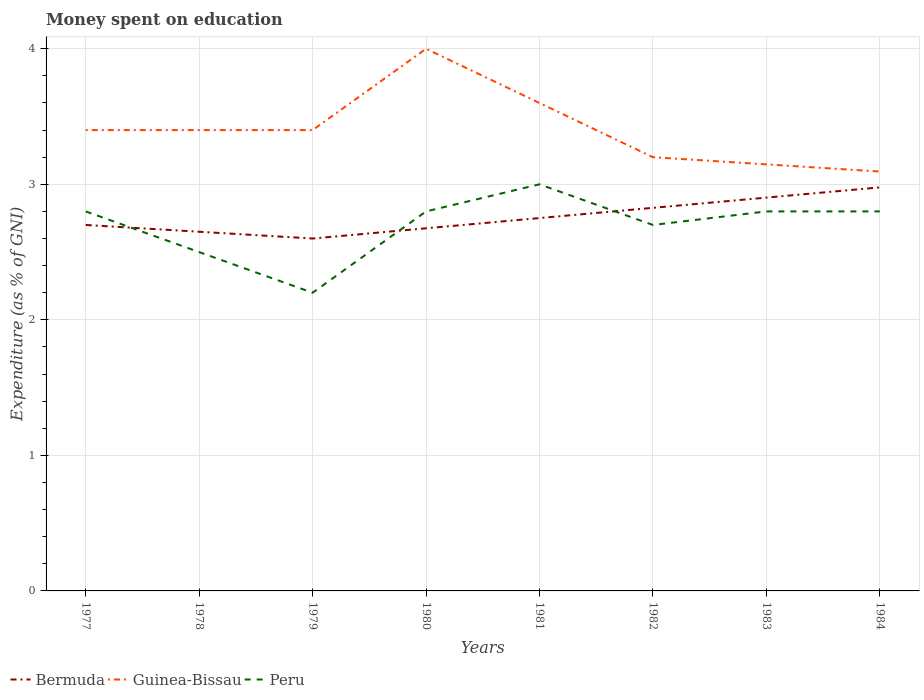How many different coloured lines are there?
Offer a very short reply. 3. Does the line corresponding to Peru intersect with the line corresponding to Bermuda?
Your answer should be very brief. Yes. Is the number of lines equal to the number of legend labels?
Make the answer very short. Yes. Across all years, what is the maximum amount of money spent on education in Guinea-Bissau?
Keep it short and to the point. 3.09. In which year was the amount of money spent on education in Peru maximum?
Ensure brevity in your answer.  1979. What is the total amount of money spent on education in Bermuda in the graph?
Offer a terse response. -0.3. What is the difference between the highest and the second highest amount of money spent on education in Guinea-Bissau?
Ensure brevity in your answer.  0.91. Is the amount of money spent on education in Peru strictly greater than the amount of money spent on education in Guinea-Bissau over the years?
Provide a succinct answer. Yes. How many lines are there?
Offer a very short reply. 3. How many years are there in the graph?
Offer a very short reply. 8. Does the graph contain any zero values?
Offer a very short reply. No. How many legend labels are there?
Offer a very short reply. 3. How are the legend labels stacked?
Your answer should be compact. Horizontal. What is the title of the graph?
Offer a terse response. Money spent on education. Does "Faeroe Islands" appear as one of the legend labels in the graph?
Offer a very short reply. No. What is the label or title of the Y-axis?
Provide a succinct answer. Expenditure (as % of GNI). What is the Expenditure (as % of GNI) in Bermuda in 1977?
Give a very brief answer. 2.7. What is the Expenditure (as % of GNI) in Guinea-Bissau in 1977?
Your answer should be compact. 3.4. What is the Expenditure (as % of GNI) in Peru in 1977?
Provide a short and direct response. 2.8. What is the Expenditure (as % of GNI) in Bermuda in 1978?
Your answer should be very brief. 2.65. What is the Expenditure (as % of GNI) of Guinea-Bissau in 1978?
Provide a succinct answer. 3.4. What is the Expenditure (as % of GNI) in Peru in 1978?
Your answer should be very brief. 2.5. What is the Expenditure (as % of GNI) in Bermuda in 1979?
Provide a succinct answer. 2.6. What is the Expenditure (as % of GNI) of Peru in 1979?
Make the answer very short. 2.2. What is the Expenditure (as % of GNI) of Bermuda in 1980?
Your answer should be compact. 2.68. What is the Expenditure (as % of GNI) of Guinea-Bissau in 1980?
Give a very brief answer. 4. What is the Expenditure (as % of GNI) of Bermuda in 1981?
Your answer should be very brief. 2.75. What is the Expenditure (as % of GNI) of Bermuda in 1982?
Give a very brief answer. 2.83. What is the Expenditure (as % of GNI) in Bermuda in 1983?
Offer a very short reply. 2.9. What is the Expenditure (as % of GNI) of Guinea-Bissau in 1983?
Provide a short and direct response. 3.15. What is the Expenditure (as % of GNI) in Bermuda in 1984?
Offer a terse response. 2.98. What is the Expenditure (as % of GNI) in Guinea-Bissau in 1984?
Give a very brief answer. 3.09. Across all years, what is the maximum Expenditure (as % of GNI) of Bermuda?
Your answer should be compact. 2.98. Across all years, what is the maximum Expenditure (as % of GNI) of Guinea-Bissau?
Offer a very short reply. 4. Across all years, what is the minimum Expenditure (as % of GNI) in Bermuda?
Ensure brevity in your answer.  2.6. Across all years, what is the minimum Expenditure (as % of GNI) of Guinea-Bissau?
Keep it short and to the point. 3.09. Across all years, what is the minimum Expenditure (as % of GNI) in Peru?
Make the answer very short. 2.2. What is the total Expenditure (as % of GNI) of Bermuda in the graph?
Offer a terse response. 22.08. What is the total Expenditure (as % of GNI) of Guinea-Bissau in the graph?
Offer a terse response. 27.24. What is the total Expenditure (as % of GNI) of Peru in the graph?
Your answer should be compact. 21.6. What is the difference between the Expenditure (as % of GNI) in Bermuda in 1977 and that in 1979?
Ensure brevity in your answer.  0.1. What is the difference between the Expenditure (as % of GNI) of Guinea-Bissau in 1977 and that in 1979?
Your response must be concise. 0. What is the difference between the Expenditure (as % of GNI) in Peru in 1977 and that in 1979?
Make the answer very short. 0.6. What is the difference between the Expenditure (as % of GNI) in Bermuda in 1977 and that in 1980?
Give a very brief answer. 0.02. What is the difference between the Expenditure (as % of GNI) in Bermuda in 1977 and that in 1981?
Provide a short and direct response. -0.05. What is the difference between the Expenditure (as % of GNI) of Guinea-Bissau in 1977 and that in 1981?
Your answer should be very brief. -0.2. What is the difference between the Expenditure (as % of GNI) in Bermuda in 1977 and that in 1982?
Your answer should be compact. -0.13. What is the difference between the Expenditure (as % of GNI) in Guinea-Bissau in 1977 and that in 1982?
Offer a very short reply. 0.2. What is the difference between the Expenditure (as % of GNI) of Peru in 1977 and that in 1982?
Make the answer very short. 0.1. What is the difference between the Expenditure (as % of GNI) in Bermuda in 1977 and that in 1983?
Offer a terse response. -0.2. What is the difference between the Expenditure (as % of GNI) in Guinea-Bissau in 1977 and that in 1983?
Provide a short and direct response. 0.25. What is the difference between the Expenditure (as % of GNI) in Peru in 1977 and that in 1983?
Give a very brief answer. 0. What is the difference between the Expenditure (as % of GNI) in Bermuda in 1977 and that in 1984?
Give a very brief answer. -0.28. What is the difference between the Expenditure (as % of GNI) in Guinea-Bissau in 1977 and that in 1984?
Provide a succinct answer. 0.31. What is the difference between the Expenditure (as % of GNI) in Peru in 1977 and that in 1984?
Your answer should be very brief. 0. What is the difference between the Expenditure (as % of GNI) in Peru in 1978 and that in 1979?
Provide a succinct answer. 0.3. What is the difference between the Expenditure (as % of GNI) in Bermuda in 1978 and that in 1980?
Make the answer very short. -0.03. What is the difference between the Expenditure (as % of GNI) of Guinea-Bissau in 1978 and that in 1980?
Your answer should be very brief. -0.6. What is the difference between the Expenditure (as % of GNI) of Peru in 1978 and that in 1980?
Provide a short and direct response. -0.3. What is the difference between the Expenditure (as % of GNI) of Bermuda in 1978 and that in 1981?
Offer a terse response. -0.1. What is the difference between the Expenditure (as % of GNI) of Guinea-Bissau in 1978 and that in 1981?
Your answer should be very brief. -0.2. What is the difference between the Expenditure (as % of GNI) in Bermuda in 1978 and that in 1982?
Provide a short and direct response. -0.18. What is the difference between the Expenditure (as % of GNI) in Bermuda in 1978 and that in 1983?
Your answer should be very brief. -0.25. What is the difference between the Expenditure (as % of GNI) of Guinea-Bissau in 1978 and that in 1983?
Your answer should be very brief. 0.25. What is the difference between the Expenditure (as % of GNI) of Peru in 1978 and that in 1983?
Provide a short and direct response. -0.3. What is the difference between the Expenditure (as % of GNI) of Bermuda in 1978 and that in 1984?
Provide a succinct answer. -0.33. What is the difference between the Expenditure (as % of GNI) of Guinea-Bissau in 1978 and that in 1984?
Your answer should be compact. 0.31. What is the difference between the Expenditure (as % of GNI) of Peru in 1978 and that in 1984?
Keep it short and to the point. -0.3. What is the difference between the Expenditure (as % of GNI) of Bermuda in 1979 and that in 1980?
Offer a very short reply. -0.08. What is the difference between the Expenditure (as % of GNI) of Bermuda in 1979 and that in 1981?
Your response must be concise. -0.15. What is the difference between the Expenditure (as % of GNI) of Guinea-Bissau in 1979 and that in 1981?
Your answer should be compact. -0.2. What is the difference between the Expenditure (as % of GNI) of Bermuda in 1979 and that in 1982?
Offer a very short reply. -0.23. What is the difference between the Expenditure (as % of GNI) in Bermuda in 1979 and that in 1983?
Offer a terse response. -0.3. What is the difference between the Expenditure (as % of GNI) in Guinea-Bissau in 1979 and that in 1983?
Provide a succinct answer. 0.25. What is the difference between the Expenditure (as % of GNI) of Bermuda in 1979 and that in 1984?
Provide a short and direct response. -0.38. What is the difference between the Expenditure (as % of GNI) in Guinea-Bissau in 1979 and that in 1984?
Keep it short and to the point. 0.31. What is the difference between the Expenditure (as % of GNI) of Bermuda in 1980 and that in 1981?
Your answer should be compact. -0.08. What is the difference between the Expenditure (as % of GNI) of Guinea-Bissau in 1980 and that in 1981?
Provide a short and direct response. 0.4. What is the difference between the Expenditure (as % of GNI) of Peru in 1980 and that in 1981?
Offer a terse response. -0.2. What is the difference between the Expenditure (as % of GNI) in Bermuda in 1980 and that in 1982?
Offer a very short reply. -0.15. What is the difference between the Expenditure (as % of GNI) in Guinea-Bissau in 1980 and that in 1982?
Keep it short and to the point. 0.8. What is the difference between the Expenditure (as % of GNI) of Peru in 1980 and that in 1982?
Offer a very short reply. 0.1. What is the difference between the Expenditure (as % of GNI) in Bermuda in 1980 and that in 1983?
Offer a terse response. -0.23. What is the difference between the Expenditure (as % of GNI) in Guinea-Bissau in 1980 and that in 1983?
Keep it short and to the point. 0.85. What is the difference between the Expenditure (as % of GNI) of Bermuda in 1980 and that in 1984?
Provide a succinct answer. -0.3. What is the difference between the Expenditure (as % of GNI) of Guinea-Bissau in 1980 and that in 1984?
Your answer should be very brief. 0.91. What is the difference between the Expenditure (as % of GNI) in Bermuda in 1981 and that in 1982?
Provide a short and direct response. -0.08. What is the difference between the Expenditure (as % of GNI) in Guinea-Bissau in 1981 and that in 1982?
Your answer should be very brief. 0.4. What is the difference between the Expenditure (as % of GNI) of Bermuda in 1981 and that in 1983?
Provide a succinct answer. -0.15. What is the difference between the Expenditure (as % of GNI) in Guinea-Bissau in 1981 and that in 1983?
Ensure brevity in your answer.  0.45. What is the difference between the Expenditure (as % of GNI) in Peru in 1981 and that in 1983?
Keep it short and to the point. 0.2. What is the difference between the Expenditure (as % of GNI) of Bermuda in 1981 and that in 1984?
Make the answer very short. -0.23. What is the difference between the Expenditure (as % of GNI) in Guinea-Bissau in 1981 and that in 1984?
Your answer should be compact. 0.51. What is the difference between the Expenditure (as % of GNI) of Bermuda in 1982 and that in 1983?
Ensure brevity in your answer.  -0.08. What is the difference between the Expenditure (as % of GNI) of Guinea-Bissau in 1982 and that in 1983?
Your response must be concise. 0.05. What is the difference between the Expenditure (as % of GNI) in Bermuda in 1982 and that in 1984?
Your response must be concise. -0.15. What is the difference between the Expenditure (as % of GNI) of Guinea-Bissau in 1982 and that in 1984?
Ensure brevity in your answer.  0.11. What is the difference between the Expenditure (as % of GNI) of Peru in 1982 and that in 1984?
Your response must be concise. -0.1. What is the difference between the Expenditure (as % of GNI) of Bermuda in 1983 and that in 1984?
Offer a terse response. -0.08. What is the difference between the Expenditure (as % of GNI) in Guinea-Bissau in 1983 and that in 1984?
Your answer should be very brief. 0.05. What is the difference between the Expenditure (as % of GNI) of Bermuda in 1977 and the Expenditure (as % of GNI) of Guinea-Bissau in 1978?
Offer a terse response. -0.7. What is the difference between the Expenditure (as % of GNI) of Guinea-Bissau in 1977 and the Expenditure (as % of GNI) of Peru in 1978?
Your response must be concise. 0.9. What is the difference between the Expenditure (as % of GNI) of Bermuda in 1977 and the Expenditure (as % of GNI) of Guinea-Bissau in 1979?
Offer a very short reply. -0.7. What is the difference between the Expenditure (as % of GNI) in Bermuda in 1977 and the Expenditure (as % of GNI) in Peru in 1980?
Provide a short and direct response. -0.1. What is the difference between the Expenditure (as % of GNI) in Bermuda in 1977 and the Expenditure (as % of GNI) in Guinea-Bissau in 1982?
Offer a terse response. -0.5. What is the difference between the Expenditure (as % of GNI) in Guinea-Bissau in 1977 and the Expenditure (as % of GNI) in Peru in 1982?
Your response must be concise. 0.7. What is the difference between the Expenditure (as % of GNI) in Bermuda in 1977 and the Expenditure (as % of GNI) in Guinea-Bissau in 1983?
Make the answer very short. -0.45. What is the difference between the Expenditure (as % of GNI) in Bermuda in 1977 and the Expenditure (as % of GNI) in Peru in 1983?
Keep it short and to the point. -0.1. What is the difference between the Expenditure (as % of GNI) in Bermuda in 1977 and the Expenditure (as % of GNI) in Guinea-Bissau in 1984?
Your response must be concise. -0.39. What is the difference between the Expenditure (as % of GNI) in Guinea-Bissau in 1977 and the Expenditure (as % of GNI) in Peru in 1984?
Your answer should be very brief. 0.6. What is the difference between the Expenditure (as % of GNI) of Bermuda in 1978 and the Expenditure (as % of GNI) of Guinea-Bissau in 1979?
Offer a terse response. -0.75. What is the difference between the Expenditure (as % of GNI) of Bermuda in 1978 and the Expenditure (as % of GNI) of Peru in 1979?
Provide a succinct answer. 0.45. What is the difference between the Expenditure (as % of GNI) in Bermuda in 1978 and the Expenditure (as % of GNI) in Guinea-Bissau in 1980?
Your answer should be very brief. -1.35. What is the difference between the Expenditure (as % of GNI) in Guinea-Bissau in 1978 and the Expenditure (as % of GNI) in Peru in 1980?
Your answer should be very brief. 0.6. What is the difference between the Expenditure (as % of GNI) of Bermuda in 1978 and the Expenditure (as % of GNI) of Guinea-Bissau in 1981?
Make the answer very short. -0.95. What is the difference between the Expenditure (as % of GNI) in Bermuda in 1978 and the Expenditure (as % of GNI) in Peru in 1981?
Your answer should be compact. -0.35. What is the difference between the Expenditure (as % of GNI) in Guinea-Bissau in 1978 and the Expenditure (as % of GNI) in Peru in 1981?
Keep it short and to the point. 0.4. What is the difference between the Expenditure (as % of GNI) of Bermuda in 1978 and the Expenditure (as % of GNI) of Guinea-Bissau in 1982?
Provide a short and direct response. -0.55. What is the difference between the Expenditure (as % of GNI) of Bermuda in 1978 and the Expenditure (as % of GNI) of Guinea-Bissau in 1983?
Give a very brief answer. -0.5. What is the difference between the Expenditure (as % of GNI) of Bermuda in 1978 and the Expenditure (as % of GNI) of Peru in 1983?
Your response must be concise. -0.15. What is the difference between the Expenditure (as % of GNI) of Bermuda in 1978 and the Expenditure (as % of GNI) of Guinea-Bissau in 1984?
Provide a succinct answer. -0.44. What is the difference between the Expenditure (as % of GNI) in Bermuda in 1978 and the Expenditure (as % of GNI) in Peru in 1984?
Offer a terse response. -0.15. What is the difference between the Expenditure (as % of GNI) in Bermuda in 1979 and the Expenditure (as % of GNI) in Peru in 1980?
Ensure brevity in your answer.  -0.2. What is the difference between the Expenditure (as % of GNI) of Guinea-Bissau in 1979 and the Expenditure (as % of GNI) of Peru in 1981?
Make the answer very short. 0.4. What is the difference between the Expenditure (as % of GNI) in Bermuda in 1979 and the Expenditure (as % of GNI) in Guinea-Bissau in 1982?
Provide a short and direct response. -0.6. What is the difference between the Expenditure (as % of GNI) of Bermuda in 1979 and the Expenditure (as % of GNI) of Peru in 1982?
Ensure brevity in your answer.  -0.1. What is the difference between the Expenditure (as % of GNI) of Guinea-Bissau in 1979 and the Expenditure (as % of GNI) of Peru in 1982?
Offer a terse response. 0.7. What is the difference between the Expenditure (as % of GNI) of Bermuda in 1979 and the Expenditure (as % of GNI) of Guinea-Bissau in 1983?
Offer a very short reply. -0.55. What is the difference between the Expenditure (as % of GNI) of Bermuda in 1979 and the Expenditure (as % of GNI) of Peru in 1983?
Keep it short and to the point. -0.2. What is the difference between the Expenditure (as % of GNI) of Guinea-Bissau in 1979 and the Expenditure (as % of GNI) of Peru in 1983?
Offer a terse response. 0.6. What is the difference between the Expenditure (as % of GNI) in Bermuda in 1979 and the Expenditure (as % of GNI) in Guinea-Bissau in 1984?
Offer a terse response. -0.49. What is the difference between the Expenditure (as % of GNI) in Guinea-Bissau in 1979 and the Expenditure (as % of GNI) in Peru in 1984?
Offer a very short reply. 0.6. What is the difference between the Expenditure (as % of GNI) of Bermuda in 1980 and the Expenditure (as % of GNI) of Guinea-Bissau in 1981?
Ensure brevity in your answer.  -0.92. What is the difference between the Expenditure (as % of GNI) in Bermuda in 1980 and the Expenditure (as % of GNI) in Peru in 1981?
Your answer should be very brief. -0.32. What is the difference between the Expenditure (as % of GNI) of Bermuda in 1980 and the Expenditure (as % of GNI) of Guinea-Bissau in 1982?
Provide a succinct answer. -0.52. What is the difference between the Expenditure (as % of GNI) of Bermuda in 1980 and the Expenditure (as % of GNI) of Peru in 1982?
Offer a terse response. -0.02. What is the difference between the Expenditure (as % of GNI) in Guinea-Bissau in 1980 and the Expenditure (as % of GNI) in Peru in 1982?
Ensure brevity in your answer.  1.3. What is the difference between the Expenditure (as % of GNI) in Bermuda in 1980 and the Expenditure (as % of GNI) in Guinea-Bissau in 1983?
Ensure brevity in your answer.  -0.47. What is the difference between the Expenditure (as % of GNI) in Bermuda in 1980 and the Expenditure (as % of GNI) in Peru in 1983?
Provide a succinct answer. -0.12. What is the difference between the Expenditure (as % of GNI) of Guinea-Bissau in 1980 and the Expenditure (as % of GNI) of Peru in 1983?
Your answer should be very brief. 1.2. What is the difference between the Expenditure (as % of GNI) in Bermuda in 1980 and the Expenditure (as % of GNI) in Guinea-Bissau in 1984?
Keep it short and to the point. -0.42. What is the difference between the Expenditure (as % of GNI) in Bermuda in 1980 and the Expenditure (as % of GNI) in Peru in 1984?
Offer a very short reply. -0.12. What is the difference between the Expenditure (as % of GNI) in Bermuda in 1981 and the Expenditure (as % of GNI) in Guinea-Bissau in 1982?
Offer a very short reply. -0.45. What is the difference between the Expenditure (as % of GNI) in Bermuda in 1981 and the Expenditure (as % of GNI) in Peru in 1982?
Provide a short and direct response. 0.05. What is the difference between the Expenditure (as % of GNI) of Guinea-Bissau in 1981 and the Expenditure (as % of GNI) of Peru in 1982?
Ensure brevity in your answer.  0.9. What is the difference between the Expenditure (as % of GNI) of Bermuda in 1981 and the Expenditure (as % of GNI) of Guinea-Bissau in 1983?
Offer a very short reply. -0.4. What is the difference between the Expenditure (as % of GNI) in Bermuda in 1981 and the Expenditure (as % of GNI) in Peru in 1983?
Ensure brevity in your answer.  -0.05. What is the difference between the Expenditure (as % of GNI) of Guinea-Bissau in 1981 and the Expenditure (as % of GNI) of Peru in 1983?
Make the answer very short. 0.8. What is the difference between the Expenditure (as % of GNI) of Bermuda in 1981 and the Expenditure (as % of GNI) of Guinea-Bissau in 1984?
Give a very brief answer. -0.34. What is the difference between the Expenditure (as % of GNI) in Bermuda in 1981 and the Expenditure (as % of GNI) in Peru in 1984?
Make the answer very short. -0.05. What is the difference between the Expenditure (as % of GNI) in Bermuda in 1982 and the Expenditure (as % of GNI) in Guinea-Bissau in 1983?
Your response must be concise. -0.32. What is the difference between the Expenditure (as % of GNI) of Bermuda in 1982 and the Expenditure (as % of GNI) of Peru in 1983?
Keep it short and to the point. 0.03. What is the difference between the Expenditure (as % of GNI) of Guinea-Bissau in 1982 and the Expenditure (as % of GNI) of Peru in 1983?
Offer a very short reply. 0.4. What is the difference between the Expenditure (as % of GNI) of Bermuda in 1982 and the Expenditure (as % of GNI) of Guinea-Bissau in 1984?
Offer a terse response. -0.27. What is the difference between the Expenditure (as % of GNI) of Bermuda in 1982 and the Expenditure (as % of GNI) of Peru in 1984?
Make the answer very short. 0.03. What is the difference between the Expenditure (as % of GNI) of Guinea-Bissau in 1982 and the Expenditure (as % of GNI) of Peru in 1984?
Give a very brief answer. 0.4. What is the difference between the Expenditure (as % of GNI) of Bermuda in 1983 and the Expenditure (as % of GNI) of Guinea-Bissau in 1984?
Ensure brevity in your answer.  -0.19. What is the difference between the Expenditure (as % of GNI) of Bermuda in 1983 and the Expenditure (as % of GNI) of Peru in 1984?
Ensure brevity in your answer.  0.1. What is the difference between the Expenditure (as % of GNI) in Guinea-Bissau in 1983 and the Expenditure (as % of GNI) in Peru in 1984?
Keep it short and to the point. 0.35. What is the average Expenditure (as % of GNI) in Bermuda per year?
Provide a short and direct response. 2.76. What is the average Expenditure (as % of GNI) of Guinea-Bissau per year?
Offer a very short reply. 3.41. In the year 1977, what is the difference between the Expenditure (as % of GNI) of Bermuda and Expenditure (as % of GNI) of Guinea-Bissau?
Your response must be concise. -0.7. In the year 1977, what is the difference between the Expenditure (as % of GNI) in Guinea-Bissau and Expenditure (as % of GNI) in Peru?
Ensure brevity in your answer.  0.6. In the year 1978, what is the difference between the Expenditure (as % of GNI) in Bermuda and Expenditure (as % of GNI) in Guinea-Bissau?
Provide a succinct answer. -0.75. In the year 1978, what is the difference between the Expenditure (as % of GNI) in Guinea-Bissau and Expenditure (as % of GNI) in Peru?
Your answer should be very brief. 0.9. In the year 1979, what is the difference between the Expenditure (as % of GNI) in Guinea-Bissau and Expenditure (as % of GNI) in Peru?
Your answer should be compact. 1.2. In the year 1980, what is the difference between the Expenditure (as % of GNI) of Bermuda and Expenditure (as % of GNI) of Guinea-Bissau?
Your response must be concise. -1.32. In the year 1980, what is the difference between the Expenditure (as % of GNI) in Bermuda and Expenditure (as % of GNI) in Peru?
Offer a terse response. -0.12. In the year 1980, what is the difference between the Expenditure (as % of GNI) in Guinea-Bissau and Expenditure (as % of GNI) in Peru?
Provide a succinct answer. 1.2. In the year 1981, what is the difference between the Expenditure (as % of GNI) in Bermuda and Expenditure (as % of GNI) in Guinea-Bissau?
Offer a very short reply. -0.85. In the year 1981, what is the difference between the Expenditure (as % of GNI) of Bermuda and Expenditure (as % of GNI) of Peru?
Your answer should be very brief. -0.25. In the year 1981, what is the difference between the Expenditure (as % of GNI) in Guinea-Bissau and Expenditure (as % of GNI) in Peru?
Provide a short and direct response. 0.6. In the year 1982, what is the difference between the Expenditure (as % of GNI) in Bermuda and Expenditure (as % of GNI) in Guinea-Bissau?
Give a very brief answer. -0.37. In the year 1982, what is the difference between the Expenditure (as % of GNI) in Bermuda and Expenditure (as % of GNI) in Peru?
Offer a terse response. 0.13. In the year 1982, what is the difference between the Expenditure (as % of GNI) in Guinea-Bissau and Expenditure (as % of GNI) in Peru?
Your response must be concise. 0.5. In the year 1983, what is the difference between the Expenditure (as % of GNI) of Bermuda and Expenditure (as % of GNI) of Guinea-Bissau?
Ensure brevity in your answer.  -0.25. In the year 1983, what is the difference between the Expenditure (as % of GNI) in Bermuda and Expenditure (as % of GNI) in Peru?
Offer a very short reply. 0.1. In the year 1983, what is the difference between the Expenditure (as % of GNI) of Guinea-Bissau and Expenditure (as % of GNI) of Peru?
Your response must be concise. 0.35. In the year 1984, what is the difference between the Expenditure (as % of GNI) in Bermuda and Expenditure (as % of GNI) in Guinea-Bissau?
Your answer should be very brief. -0.12. In the year 1984, what is the difference between the Expenditure (as % of GNI) in Bermuda and Expenditure (as % of GNI) in Peru?
Offer a terse response. 0.18. In the year 1984, what is the difference between the Expenditure (as % of GNI) of Guinea-Bissau and Expenditure (as % of GNI) of Peru?
Keep it short and to the point. 0.29. What is the ratio of the Expenditure (as % of GNI) in Bermuda in 1977 to that in 1978?
Your answer should be very brief. 1.02. What is the ratio of the Expenditure (as % of GNI) in Guinea-Bissau in 1977 to that in 1978?
Ensure brevity in your answer.  1. What is the ratio of the Expenditure (as % of GNI) of Peru in 1977 to that in 1978?
Offer a terse response. 1.12. What is the ratio of the Expenditure (as % of GNI) in Bermuda in 1977 to that in 1979?
Your answer should be compact. 1.04. What is the ratio of the Expenditure (as % of GNI) of Guinea-Bissau in 1977 to that in 1979?
Give a very brief answer. 1. What is the ratio of the Expenditure (as % of GNI) of Peru in 1977 to that in 1979?
Provide a succinct answer. 1.27. What is the ratio of the Expenditure (as % of GNI) of Bermuda in 1977 to that in 1980?
Give a very brief answer. 1.01. What is the ratio of the Expenditure (as % of GNI) of Guinea-Bissau in 1977 to that in 1980?
Your response must be concise. 0.85. What is the ratio of the Expenditure (as % of GNI) of Bermuda in 1977 to that in 1981?
Your answer should be very brief. 0.98. What is the ratio of the Expenditure (as % of GNI) of Guinea-Bissau in 1977 to that in 1981?
Make the answer very short. 0.94. What is the ratio of the Expenditure (as % of GNI) of Peru in 1977 to that in 1981?
Keep it short and to the point. 0.93. What is the ratio of the Expenditure (as % of GNI) in Bermuda in 1977 to that in 1982?
Your response must be concise. 0.96. What is the ratio of the Expenditure (as % of GNI) in Peru in 1977 to that in 1982?
Keep it short and to the point. 1.04. What is the ratio of the Expenditure (as % of GNI) in Bermuda in 1977 to that in 1983?
Keep it short and to the point. 0.93. What is the ratio of the Expenditure (as % of GNI) of Guinea-Bissau in 1977 to that in 1983?
Keep it short and to the point. 1.08. What is the ratio of the Expenditure (as % of GNI) of Peru in 1977 to that in 1983?
Provide a succinct answer. 1. What is the ratio of the Expenditure (as % of GNI) in Bermuda in 1977 to that in 1984?
Give a very brief answer. 0.91. What is the ratio of the Expenditure (as % of GNI) in Guinea-Bissau in 1977 to that in 1984?
Your answer should be very brief. 1.1. What is the ratio of the Expenditure (as % of GNI) of Bermuda in 1978 to that in 1979?
Provide a succinct answer. 1.02. What is the ratio of the Expenditure (as % of GNI) of Guinea-Bissau in 1978 to that in 1979?
Keep it short and to the point. 1. What is the ratio of the Expenditure (as % of GNI) of Peru in 1978 to that in 1979?
Provide a succinct answer. 1.14. What is the ratio of the Expenditure (as % of GNI) in Bermuda in 1978 to that in 1980?
Your answer should be compact. 0.99. What is the ratio of the Expenditure (as % of GNI) of Guinea-Bissau in 1978 to that in 1980?
Provide a succinct answer. 0.85. What is the ratio of the Expenditure (as % of GNI) of Peru in 1978 to that in 1980?
Your answer should be very brief. 0.89. What is the ratio of the Expenditure (as % of GNI) of Bermuda in 1978 to that in 1981?
Ensure brevity in your answer.  0.96. What is the ratio of the Expenditure (as % of GNI) in Guinea-Bissau in 1978 to that in 1981?
Keep it short and to the point. 0.94. What is the ratio of the Expenditure (as % of GNI) in Peru in 1978 to that in 1981?
Provide a short and direct response. 0.83. What is the ratio of the Expenditure (as % of GNI) of Bermuda in 1978 to that in 1982?
Your response must be concise. 0.94. What is the ratio of the Expenditure (as % of GNI) in Guinea-Bissau in 1978 to that in 1982?
Your answer should be very brief. 1.06. What is the ratio of the Expenditure (as % of GNI) in Peru in 1978 to that in 1982?
Your answer should be compact. 0.93. What is the ratio of the Expenditure (as % of GNI) of Bermuda in 1978 to that in 1983?
Your answer should be compact. 0.91. What is the ratio of the Expenditure (as % of GNI) of Guinea-Bissau in 1978 to that in 1983?
Offer a terse response. 1.08. What is the ratio of the Expenditure (as % of GNI) of Peru in 1978 to that in 1983?
Ensure brevity in your answer.  0.89. What is the ratio of the Expenditure (as % of GNI) in Bermuda in 1978 to that in 1984?
Offer a very short reply. 0.89. What is the ratio of the Expenditure (as % of GNI) in Guinea-Bissau in 1978 to that in 1984?
Offer a very short reply. 1.1. What is the ratio of the Expenditure (as % of GNI) in Peru in 1978 to that in 1984?
Ensure brevity in your answer.  0.89. What is the ratio of the Expenditure (as % of GNI) in Bermuda in 1979 to that in 1980?
Your answer should be very brief. 0.97. What is the ratio of the Expenditure (as % of GNI) of Peru in 1979 to that in 1980?
Keep it short and to the point. 0.79. What is the ratio of the Expenditure (as % of GNI) of Bermuda in 1979 to that in 1981?
Make the answer very short. 0.95. What is the ratio of the Expenditure (as % of GNI) of Peru in 1979 to that in 1981?
Your answer should be very brief. 0.73. What is the ratio of the Expenditure (as % of GNI) in Bermuda in 1979 to that in 1982?
Ensure brevity in your answer.  0.92. What is the ratio of the Expenditure (as % of GNI) of Guinea-Bissau in 1979 to that in 1982?
Provide a short and direct response. 1.06. What is the ratio of the Expenditure (as % of GNI) of Peru in 1979 to that in 1982?
Keep it short and to the point. 0.81. What is the ratio of the Expenditure (as % of GNI) in Bermuda in 1979 to that in 1983?
Your answer should be very brief. 0.9. What is the ratio of the Expenditure (as % of GNI) in Guinea-Bissau in 1979 to that in 1983?
Your answer should be very brief. 1.08. What is the ratio of the Expenditure (as % of GNI) in Peru in 1979 to that in 1983?
Offer a very short reply. 0.79. What is the ratio of the Expenditure (as % of GNI) in Bermuda in 1979 to that in 1984?
Provide a short and direct response. 0.87. What is the ratio of the Expenditure (as % of GNI) in Guinea-Bissau in 1979 to that in 1984?
Your response must be concise. 1.1. What is the ratio of the Expenditure (as % of GNI) in Peru in 1979 to that in 1984?
Offer a terse response. 0.79. What is the ratio of the Expenditure (as % of GNI) in Bermuda in 1980 to that in 1981?
Offer a terse response. 0.97. What is the ratio of the Expenditure (as % of GNI) of Guinea-Bissau in 1980 to that in 1981?
Offer a very short reply. 1.11. What is the ratio of the Expenditure (as % of GNI) of Bermuda in 1980 to that in 1982?
Offer a terse response. 0.95. What is the ratio of the Expenditure (as % of GNI) of Bermuda in 1980 to that in 1983?
Offer a terse response. 0.92. What is the ratio of the Expenditure (as % of GNI) of Guinea-Bissau in 1980 to that in 1983?
Your answer should be compact. 1.27. What is the ratio of the Expenditure (as % of GNI) of Peru in 1980 to that in 1983?
Provide a short and direct response. 1. What is the ratio of the Expenditure (as % of GNI) in Bermuda in 1980 to that in 1984?
Provide a succinct answer. 0.9. What is the ratio of the Expenditure (as % of GNI) of Guinea-Bissau in 1980 to that in 1984?
Your answer should be very brief. 1.29. What is the ratio of the Expenditure (as % of GNI) in Peru in 1980 to that in 1984?
Keep it short and to the point. 1. What is the ratio of the Expenditure (as % of GNI) in Bermuda in 1981 to that in 1982?
Offer a terse response. 0.97. What is the ratio of the Expenditure (as % of GNI) in Guinea-Bissau in 1981 to that in 1982?
Your response must be concise. 1.12. What is the ratio of the Expenditure (as % of GNI) in Bermuda in 1981 to that in 1983?
Keep it short and to the point. 0.95. What is the ratio of the Expenditure (as % of GNI) of Guinea-Bissau in 1981 to that in 1983?
Keep it short and to the point. 1.14. What is the ratio of the Expenditure (as % of GNI) of Peru in 1981 to that in 1983?
Your answer should be compact. 1.07. What is the ratio of the Expenditure (as % of GNI) in Bermuda in 1981 to that in 1984?
Keep it short and to the point. 0.92. What is the ratio of the Expenditure (as % of GNI) of Guinea-Bissau in 1981 to that in 1984?
Your answer should be compact. 1.16. What is the ratio of the Expenditure (as % of GNI) in Peru in 1981 to that in 1984?
Ensure brevity in your answer.  1.07. What is the ratio of the Expenditure (as % of GNI) of Bermuda in 1982 to that in 1983?
Give a very brief answer. 0.97. What is the ratio of the Expenditure (as % of GNI) of Guinea-Bissau in 1982 to that in 1983?
Your answer should be very brief. 1.02. What is the ratio of the Expenditure (as % of GNI) in Bermuda in 1982 to that in 1984?
Your answer should be compact. 0.95. What is the ratio of the Expenditure (as % of GNI) in Guinea-Bissau in 1982 to that in 1984?
Offer a very short reply. 1.03. What is the ratio of the Expenditure (as % of GNI) in Peru in 1982 to that in 1984?
Provide a short and direct response. 0.96. What is the ratio of the Expenditure (as % of GNI) in Bermuda in 1983 to that in 1984?
Provide a succinct answer. 0.97. What is the ratio of the Expenditure (as % of GNI) of Guinea-Bissau in 1983 to that in 1984?
Ensure brevity in your answer.  1.02. What is the difference between the highest and the second highest Expenditure (as % of GNI) of Bermuda?
Your answer should be very brief. 0.08. What is the difference between the highest and the second highest Expenditure (as % of GNI) in Guinea-Bissau?
Give a very brief answer. 0.4. What is the difference between the highest and the lowest Expenditure (as % of GNI) in Bermuda?
Ensure brevity in your answer.  0.38. What is the difference between the highest and the lowest Expenditure (as % of GNI) in Guinea-Bissau?
Provide a succinct answer. 0.91. What is the difference between the highest and the lowest Expenditure (as % of GNI) of Peru?
Make the answer very short. 0.8. 